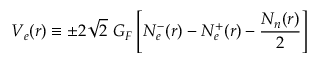Convert formula to latex. <formula><loc_0><loc_0><loc_500><loc_500>V _ { e } ( r ) \equiv \pm 2 \sqrt { 2 } \ G _ { F } \left [ N _ { e } ^ { - } ( r ) - N _ { e } ^ { + } ( r ) - \frac { N _ { n } ( r ) } { 2 } \right ]</formula> 